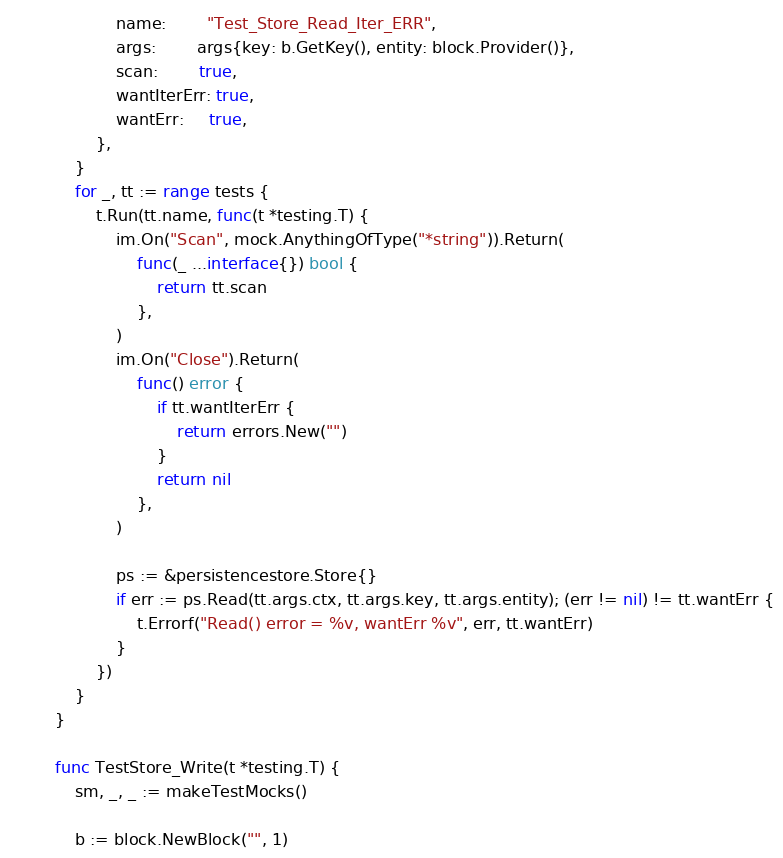<code> <loc_0><loc_0><loc_500><loc_500><_Go_>			name:        "Test_Store_Read_Iter_ERR",
			args:        args{key: b.GetKey(), entity: block.Provider()},
			scan:        true,
			wantIterErr: true,
			wantErr:     true,
		},
	}
	for _, tt := range tests {
		t.Run(tt.name, func(t *testing.T) {
			im.On("Scan", mock.AnythingOfType("*string")).Return(
				func(_ ...interface{}) bool {
					return tt.scan
				},
			)
			im.On("Close").Return(
				func() error {
					if tt.wantIterErr {
						return errors.New("")
					}
					return nil
				},
			)

			ps := &persistencestore.Store{}
			if err := ps.Read(tt.args.ctx, tt.args.key, tt.args.entity); (err != nil) != tt.wantErr {
				t.Errorf("Read() error = %v, wantErr %v", err, tt.wantErr)
			}
		})
	}
}

func TestStore_Write(t *testing.T) {
	sm, _, _ := makeTestMocks()

	b := block.NewBlock("", 1)</code> 